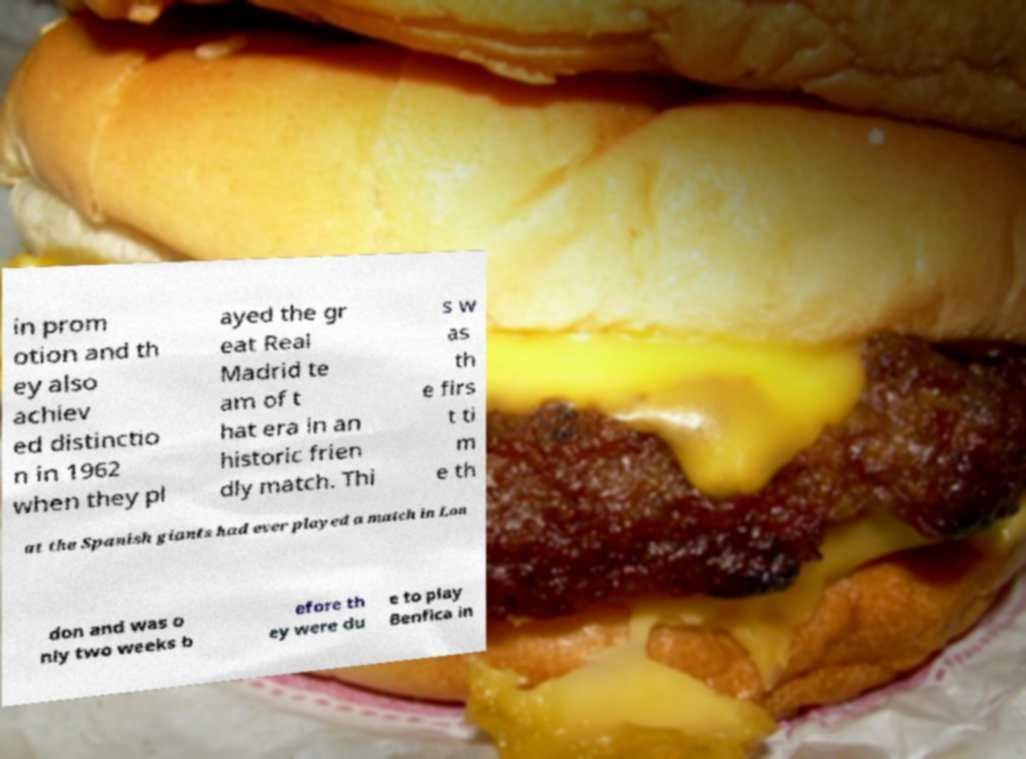Please read and relay the text visible in this image. What does it say? in prom otion and th ey also achiev ed distinctio n in 1962 when they pl ayed the gr eat Real Madrid te am of t hat era in an historic frien dly match. Thi s w as th e firs t ti m e th at the Spanish giants had ever played a match in Lon don and was o nly two weeks b efore th ey were du e to play Benfica in 